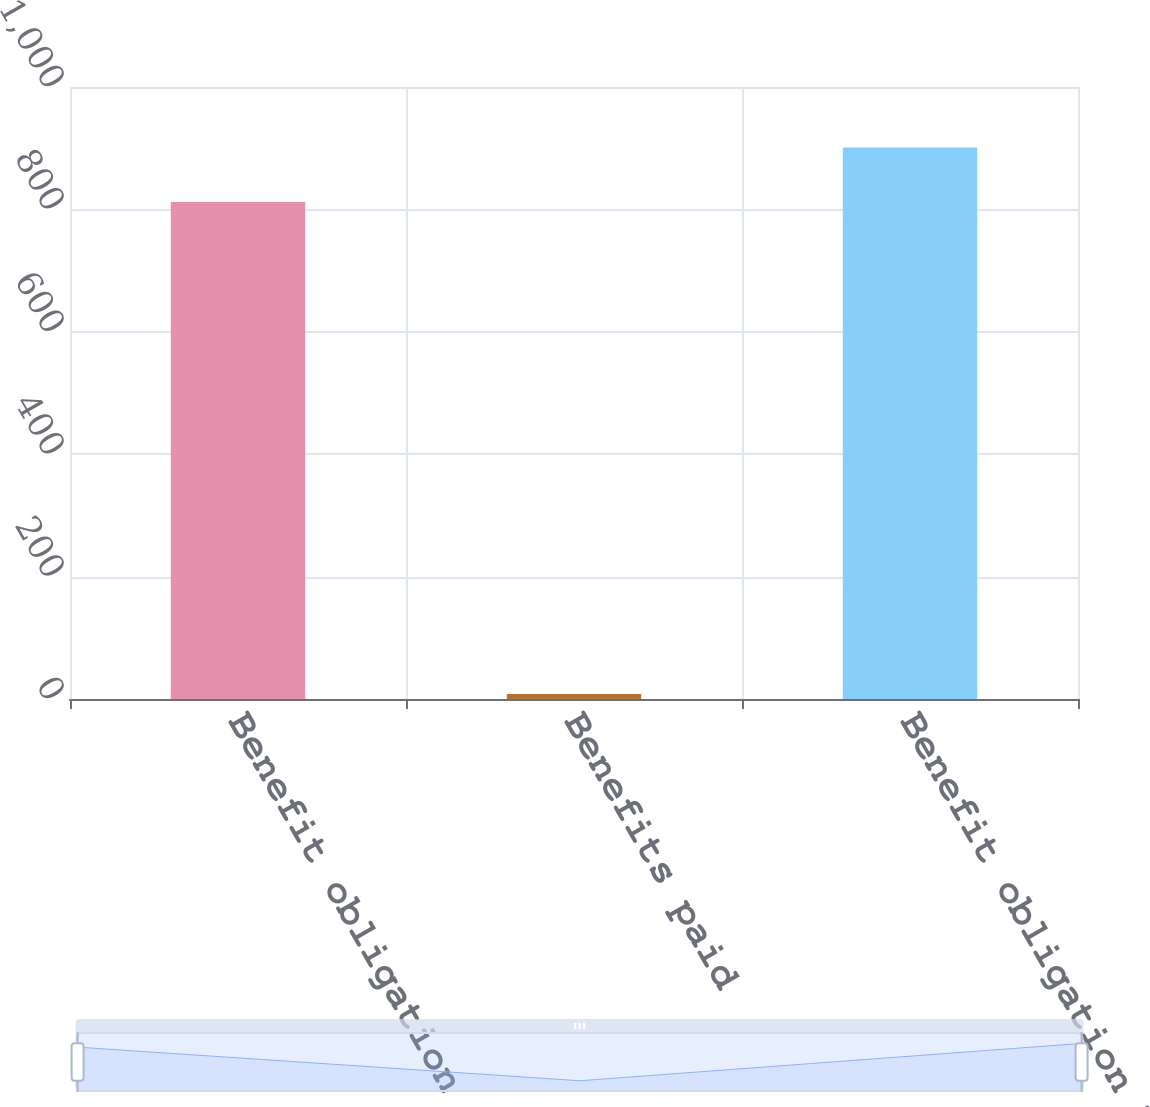Convert chart to OTSL. <chart><loc_0><loc_0><loc_500><loc_500><bar_chart><fcel>Benefit obligation January 1<fcel>Benefits paid<fcel>Benefit obligation December 31<nl><fcel>812<fcel>8<fcel>901.1<nl></chart> 